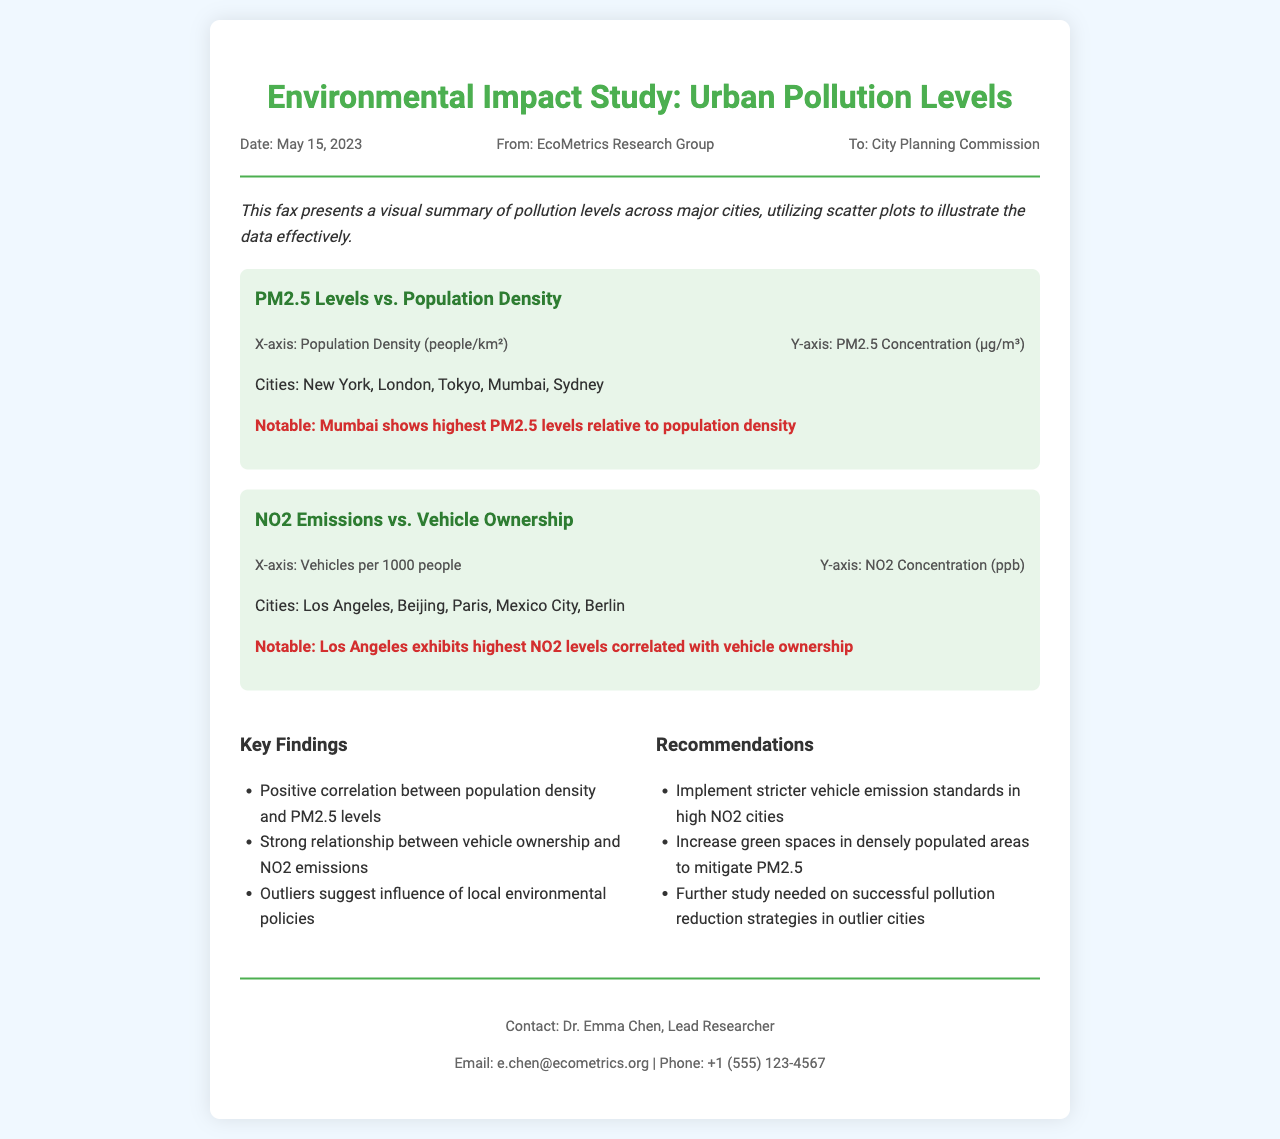What is the title of the study? The title is stated prominently at the top of the fax, indicating the focus of the document.
Answer: Environmental Impact Study: Urban Pollution Levels What date was the fax sent? The date is included in the header information section, providing a reference point for the document's timing.
Answer: May 15, 2023 Who is the sender of the fax? The sender's name is mentioned in the header information, indicating the origin of the study.
Answer: EcoMetrics Research Group Which city has the highest PM2.5 levels? This information is highlighted in the notable point section under the PM2.5 scatter plot.
Answer: Mumbai What is the X-axis label for the NO2 emissions scatter plot? The axis labels are provided below each scatter plot to clarify what each axis represents.
Answer: Vehicles per 1000 people What is one key finding related to population density? The findings section outlines a specific relationship between the variables, allowing for a direct answer.
Answer: Positive correlation between population density and PM2.5 levels What recommendation is made for high NO2 cities? The recommendations section offers specific solutions based on the findings of the study.
Answer: Implement stricter vehicle emission standards Who is the lead researcher? The footer presents contact information, including the name of the lead researcher associated with the study.
Answer: Dr. Emma Chen What is the Y-axis label for the PM2.5 levels scatter plot? This detail is found in the axis information section below the PM2.5 scatter plot, describing the vertical measurement.
Answer: PM2.5 Concentration (µg/m³) 